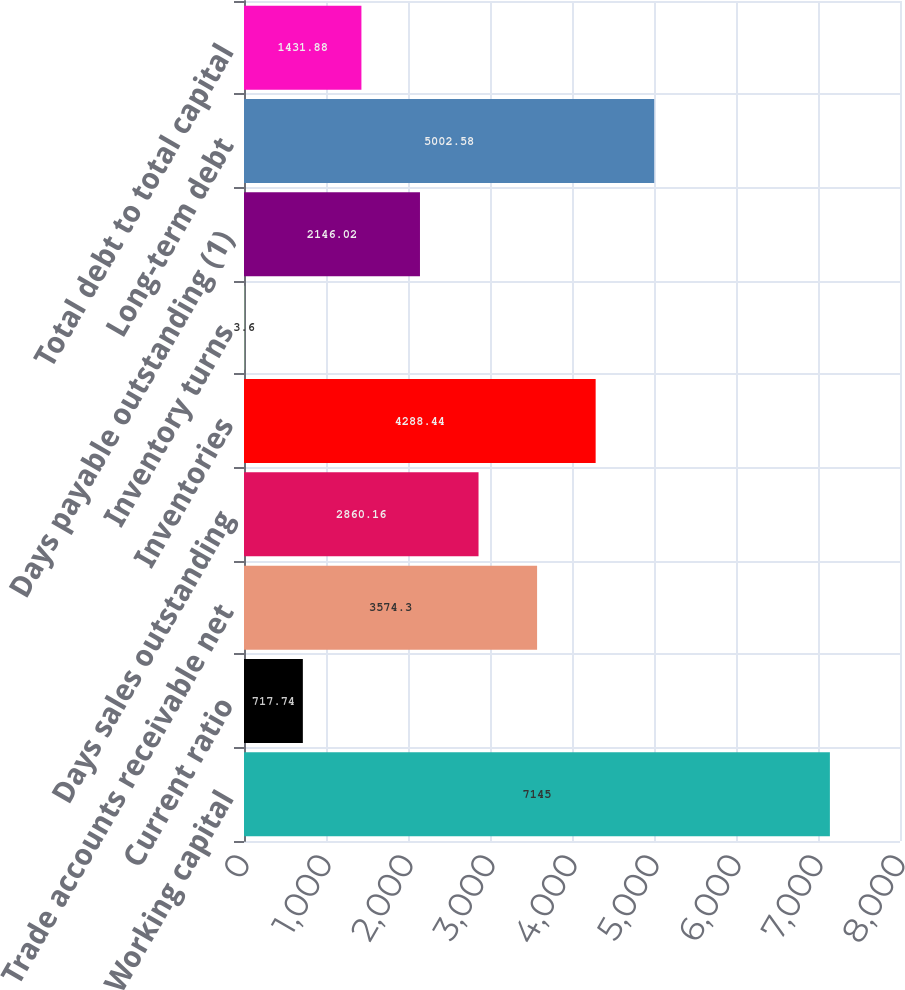<chart> <loc_0><loc_0><loc_500><loc_500><bar_chart><fcel>Working capital<fcel>Current ratio<fcel>Trade accounts receivable net<fcel>Days sales outstanding<fcel>Inventories<fcel>Inventory turns<fcel>Days payable outstanding (1)<fcel>Long-term debt<fcel>Total debt to total capital<nl><fcel>7145<fcel>717.74<fcel>3574.3<fcel>2860.16<fcel>4288.44<fcel>3.6<fcel>2146.02<fcel>5002.58<fcel>1431.88<nl></chart> 